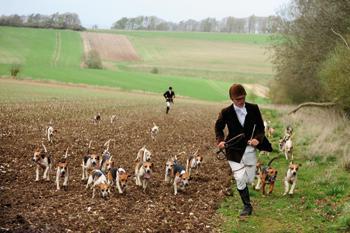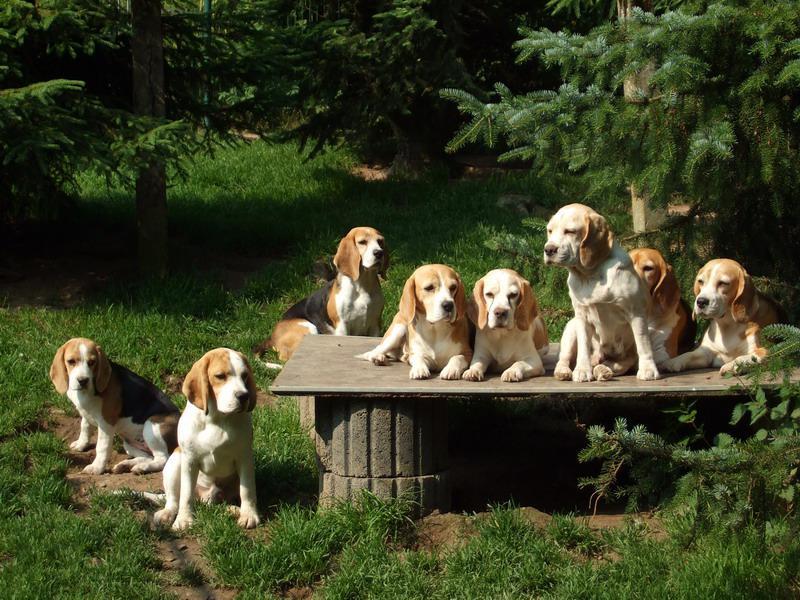The first image is the image on the left, the second image is the image on the right. For the images shown, is this caption "The picture on the right is in black and white." true? Answer yes or no. No. The first image is the image on the left, the second image is the image on the right. For the images shown, is this caption "No humans are in sight in one of the images of hounds." true? Answer yes or no. Yes. 